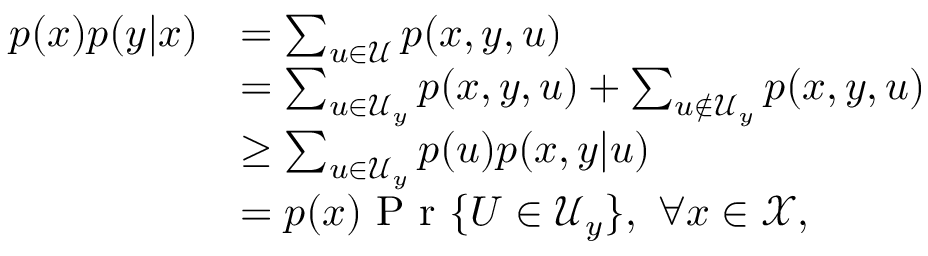<formula> <loc_0><loc_0><loc_500><loc_500>\begin{array} { r l } { p ( x ) p ( y | x ) } & { = \sum _ { u \in \mathcal { U } } p ( x , y , u ) } \\ & { = \sum _ { u \in \mathcal { U } _ { y } } p ( x , y , u ) + \sum _ { u \not \in \mathcal { U } _ { y } } p ( x , y , u ) } \\ & { \geq \sum _ { u \in \mathcal { U } _ { y } } p ( u ) p ( x , y | u ) } \\ & { = p ( x ) P r \{ U \in \mathcal { U } _ { y } \} , \ \forall x \in \mathcal { X } , } \end{array}</formula> 